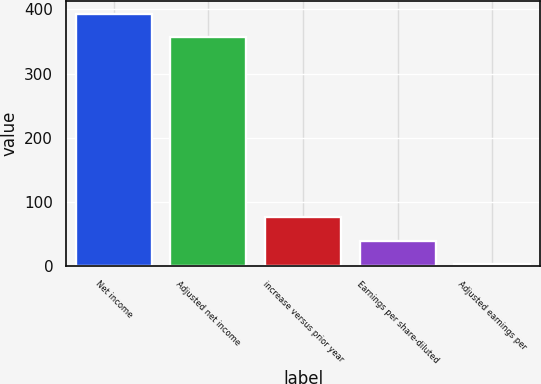Convert chart to OTSL. <chart><loc_0><loc_0><loc_500><loc_500><bar_chart><fcel>Net income<fcel>Adjusted net income<fcel>increase versus prior year<fcel>Earnings per share-diluted<fcel>Adjusted earnings per<nl><fcel>393.06<fcel>356.3<fcel>76.16<fcel>39.41<fcel>2.65<nl></chart> 